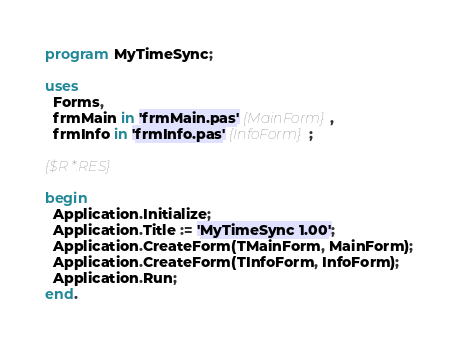<code> <loc_0><loc_0><loc_500><loc_500><_Pascal_>program MyTimeSync;

uses
  Forms,
  frmMain in 'frmMain.pas' {MainForm},
  frmInfo in 'frmInfo.pas' {InfoForm};

{$R *.RES}

begin
  Application.Initialize;
  Application.Title := 'MyTimeSync 1.00';
  Application.CreateForm(TMainForm, MainForm);
  Application.CreateForm(TInfoForm, InfoForm);
  Application.Run;
end.
</code> 